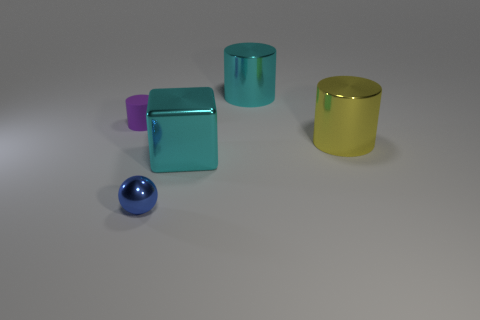What is the size of the metal cylinder that is the same color as the shiny block?
Provide a short and direct response. Large. There is a purple rubber thing left of the big object that is right of the cyan metal thing that is to the right of the metallic block; what is its size?
Make the answer very short. Small. How many large yellow objects have the same material as the tiny blue object?
Offer a very short reply. 1. What number of blue things are the same size as the yellow object?
Your answer should be very brief. 0. What is the cylinder that is behind the small object behind the cyan thing that is in front of the small purple matte cylinder made of?
Your answer should be compact. Metal. What number of objects are either purple matte objects or small cubes?
Give a very brief answer. 1. Is there anything else that has the same material as the purple cylinder?
Offer a terse response. No. There is a tiny blue metal thing; what shape is it?
Your response must be concise. Sphere. What shape is the cyan object that is to the left of the big cyan shiny object that is on the right side of the cyan block?
Make the answer very short. Cube. Is the material of the cyan object right of the metallic cube the same as the tiny blue thing?
Provide a succinct answer. Yes. 